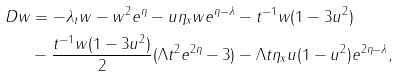Convert formula to latex. <formula><loc_0><loc_0><loc_500><loc_500>D w & = - \lambda _ { t } w - w ^ { 2 } e ^ { \eta } - u \eta _ { x } w e ^ { \eta - \lambda } - t ^ { - 1 } w ( 1 - 3 u ^ { 2 } ) \\ & - \frac { t ^ { - 1 } w ( 1 - 3 u ^ { 2 } ) } { 2 } ( \Lambda t ^ { 2 } e ^ { 2 \eta } - 3 ) - \Lambda t \eta _ { x } u ( 1 - u ^ { 2 } ) e ^ { 2 \eta - \lambda } ,</formula> 